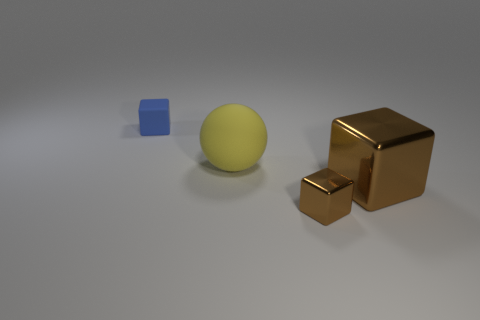Subtract all blue rubber blocks. How many blocks are left? 2 Subtract all cubes. How many objects are left? 1 Add 4 brown shiny things. How many objects exist? 8 Subtract all blue cubes. How many cubes are left? 2 Subtract all blue spheres. How many red blocks are left? 0 Subtract all blue rubber objects. Subtract all blocks. How many objects are left? 0 Add 4 big shiny cubes. How many big shiny cubes are left? 5 Add 3 tiny blue matte things. How many tiny blue matte things exist? 4 Subtract 0 blue cylinders. How many objects are left? 4 Subtract 1 spheres. How many spheres are left? 0 